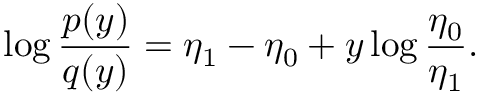Convert formula to latex. <formula><loc_0><loc_0><loc_500><loc_500>\log \frac { p ( y ) } { q ( y ) } = \eta _ { 1 } - \eta _ { 0 } + y \log \frac { \eta _ { 0 } } { \eta _ { 1 } } .</formula> 